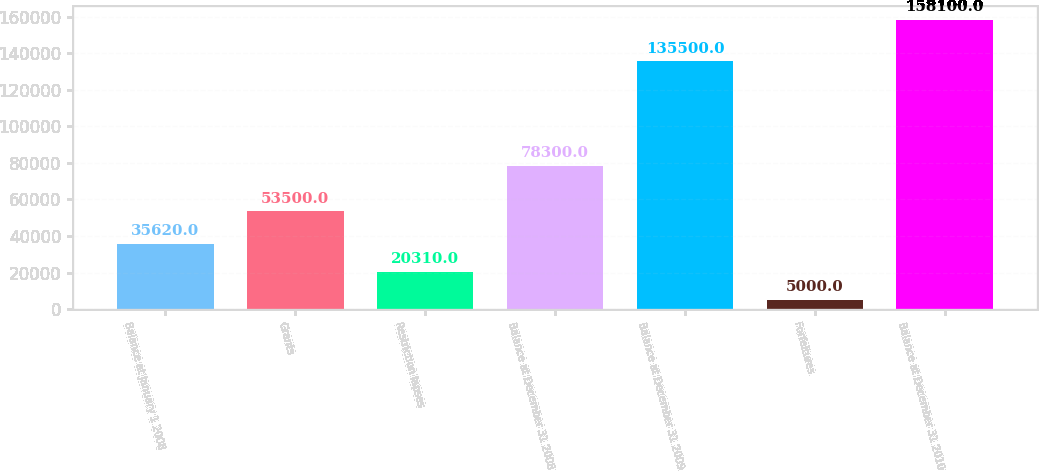Convert chart. <chart><loc_0><loc_0><loc_500><loc_500><bar_chart><fcel>Balance at January 1 2008<fcel>Grants<fcel>Restriction lapses<fcel>Balance at December 31 2008<fcel>Balance at December 31 2009<fcel>Forfeitures<fcel>Balance at December 31 2010<nl><fcel>35620<fcel>53500<fcel>20310<fcel>78300<fcel>135500<fcel>5000<fcel>158100<nl></chart> 